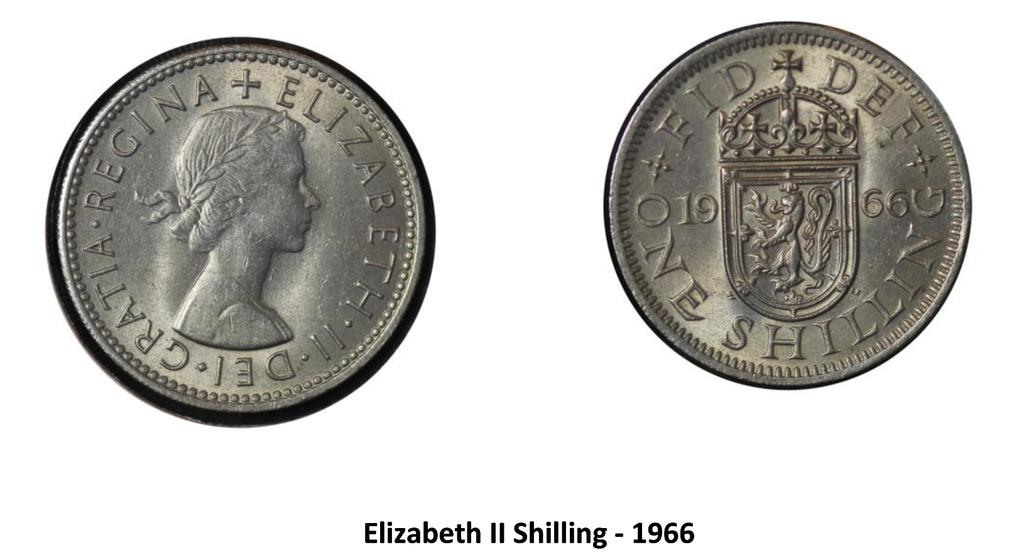<image>
Present a compact description of the photo's key features. An Elizabeth II shilling is dated 1966 and is silver in color. 